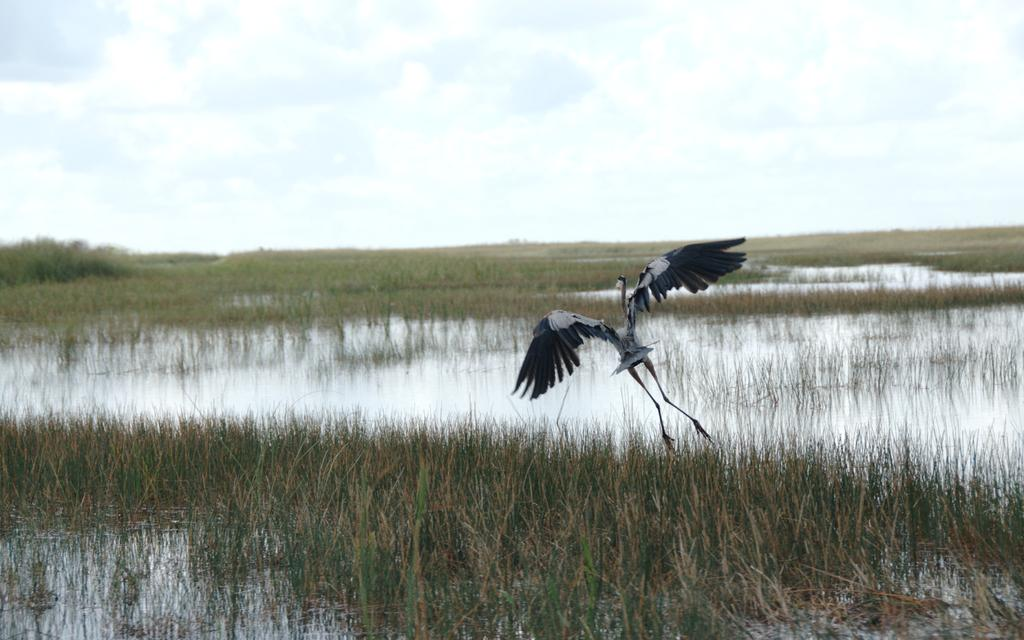What type of vegetation can be seen in the image? There is grass in the image. What else is present in the image besides grass? There is water and a bird flying in the air in the image. What can be seen in the background of the image? The sky is visible in the background of the image. What is the condition of the sky in the image? Clouds are present in the sky. Where is the engine located in the image? There is no engine present in the image. Can you tell me how many dinosaurs are walking in the grass in the image? There are no dinosaurs present in the image; it features grass, water, a bird, and a sky with clouds. What type of vase can be seen in the image? There is no vase present in the image. 